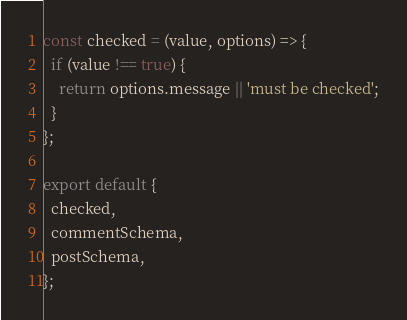<code> <loc_0><loc_0><loc_500><loc_500><_JavaScript_>const checked = (value, options) => {
  if (value !== true) {
    return options.message || 'must be checked';
  }
};

export default {
  checked,
  commentSchema,
  postSchema,
};
</code> 